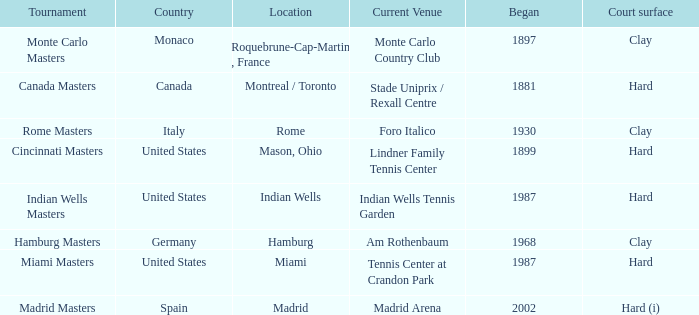Would you be able to parse every entry in this table? {'header': ['Tournament', 'Country', 'Location', 'Current Venue', 'Began', 'Court surface'], 'rows': [['Monte Carlo Masters', 'Monaco', 'Roquebrune-Cap-Martin , France', 'Monte Carlo Country Club', '1897', 'Clay'], ['Canada Masters', 'Canada', 'Montreal / Toronto', 'Stade Uniprix / Rexall Centre', '1881', 'Hard'], ['Rome Masters', 'Italy', 'Rome', 'Foro Italico', '1930', 'Clay'], ['Cincinnati Masters', 'United States', 'Mason, Ohio', 'Lindner Family Tennis Center', '1899', 'Hard'], ['Indian Wells Masters', 'United States', 'Indian Wells', 'Indian Wells Tennis Garden', '1987', 'Hard'], ['Hamburg Masters', 'Germany', 'Hamburg', 'Am Rothenbaum', '1968', 'Clay'], ['Miami Masters', 'United States', 'Miami', 'Tennis Center at Crandon Park', '1987', 'Hard'], ['Madrid Masters', 'Spain', 'Madrid', 'Madrid Arena', '2002', 'Hard (i)']]} How many tournaments have their current venue as the Lindner Family Tennis Center? 1.0. 